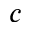<formula> <loc_0><loc_0><loc_500><loc_500>c</formula> 